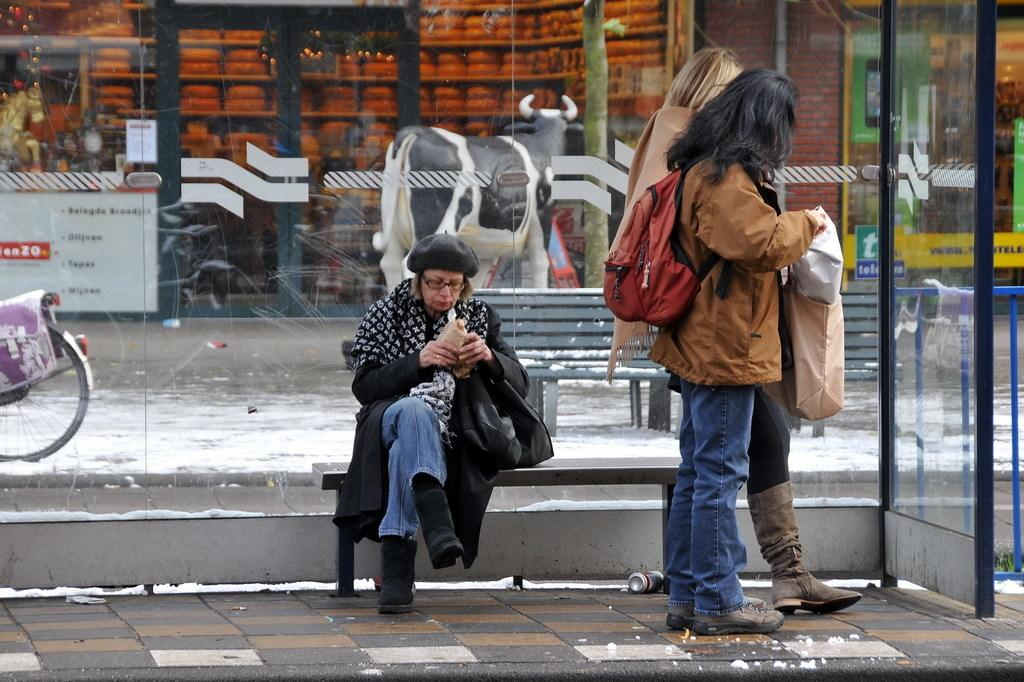How many people are standing on the footpath in the image? There are two persons standing on a footpath in the image. What is the woman doing in the image? The woman is sitting on a bench in the image. What can be seen in the background of the image? In the background, there is a glass and bench, shops, and a sculpture of a cow. What type of payment is accepted at the window in the image? There is no window present in the image, so it is not possible to determine what type of payment might be accepted. 